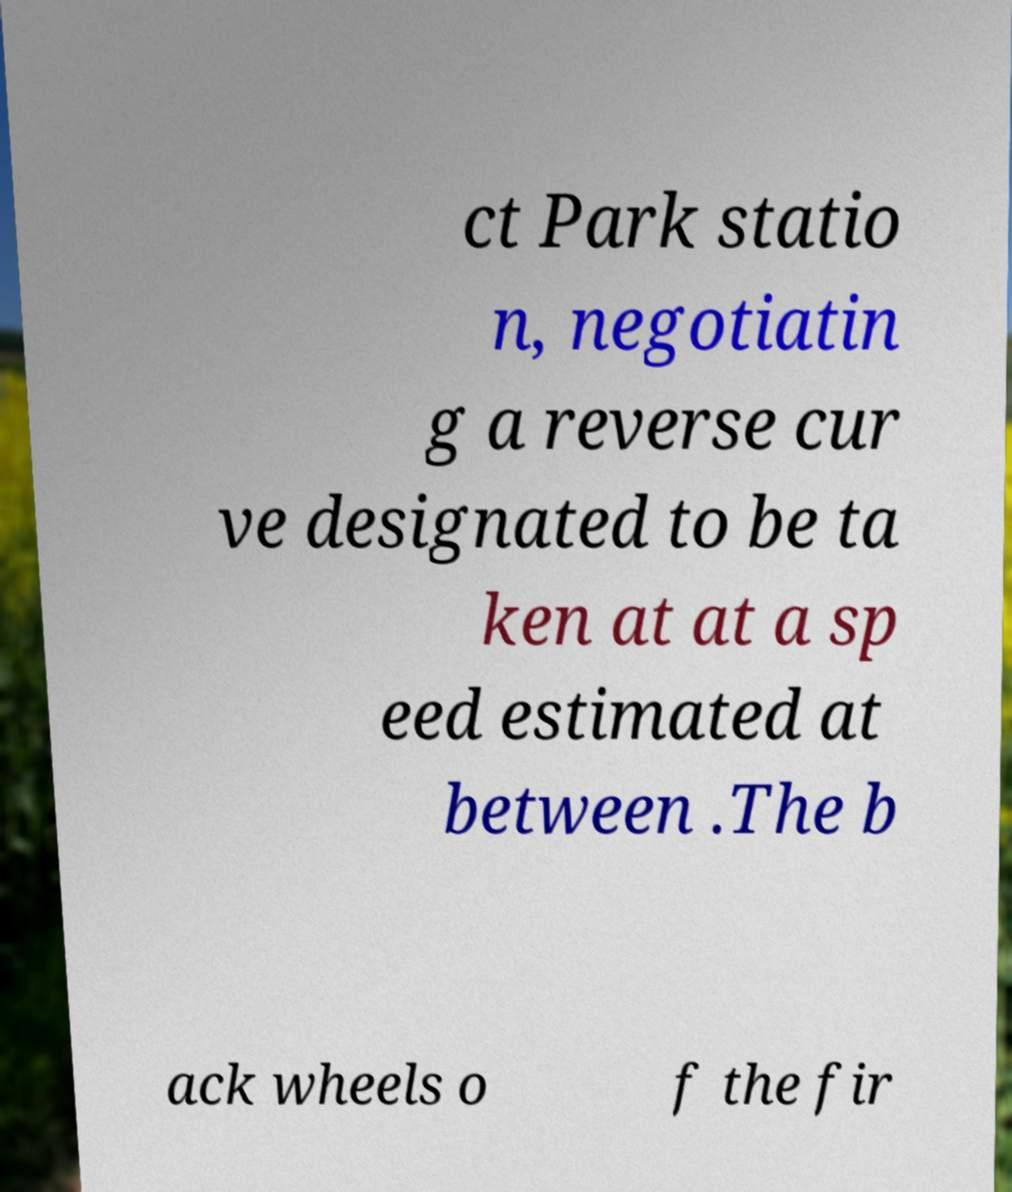Can you accurately transcribe the text from the provided image for me? ct Park statio n, negotiatin g a reverse cur ve designated to be ta ken at at a sp eed estimated at between .The b ack wheels o f the fir 